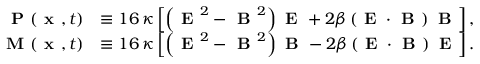Convert formula to latex. <formula><loc_0><loc_0><loc_500><loc_500>\begin{array} { r l } { P ( x , t ) } & { \equiv 1 6 \, \kappa \left [ \left ( E ^ { 2 } - B ^ { 2 } \right ) E + 2 \beta \left ( E \cdot B \right ) B \right ] , } \\ { M ( x , t ) } & { \equiv 1 6 \, \kappa \left [ \left ( E ^ { 2 } - B ^ { 2 } \right ) B - 2 \beta \left ( E \cdot B \right ) E \right ] . } \end{array}</formula> 